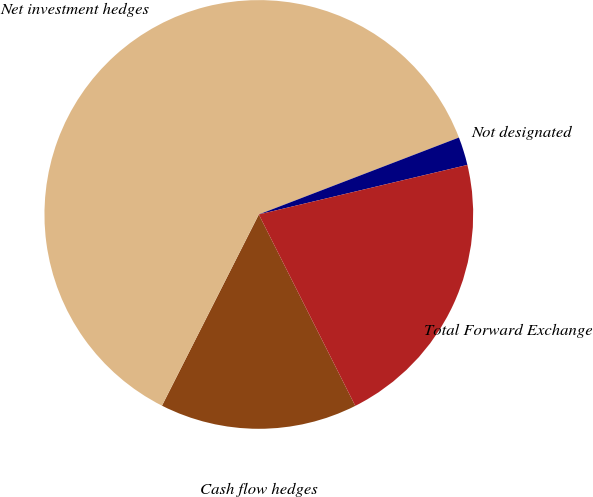<chart> <loc_0><loc_0><loc_500><loc_500><pie_chart><fcel>Cash flow hedges<fcel>Net investment hedges<fcel>Not designated<fcel>Total Forward Exchange<nl><fcel>14.89%<fcel>61.7%<fcel>2.13%<fcel>21.28%<nl></chart> 